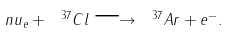<formula> <loc_0><loc_0><loc_500><loc_500>\ n u _ { e } + \ ^ { 3 7 } C l \longrightarrow \ ^ { 3 7 } A r + e ^ { - } .</formula> 